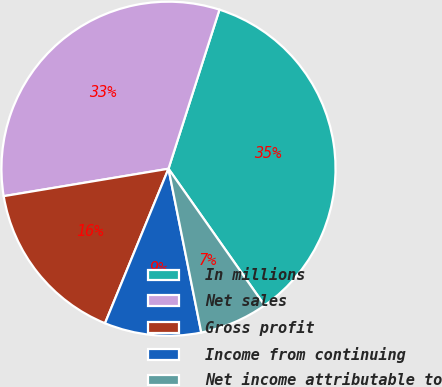<chart> <loc_0><loc_0><loc_500><loc_500><pie_chart><fcel>In millions<fcel>Net sales<fcel>Gross profit<fcel>Income from continuing<fcel>Net income attributable to<nl><fcel>35.31%<fcel>32.56%<fcel>16.17%<fcel>9.35%<fcel>6.61%<nl></chart> 